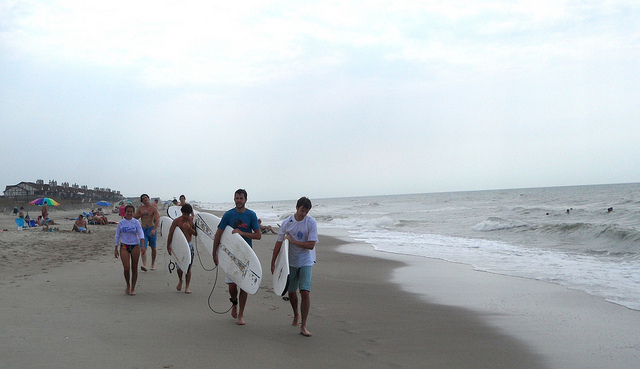Can you tell what the weather looks like? The sky is predominantly overcast with no direct sunlight visible, indicating a cloudy day at the beach. The conditions may be cooler and less ideal for sunbathing but suitable for surfing or a casual walk along the shore. 